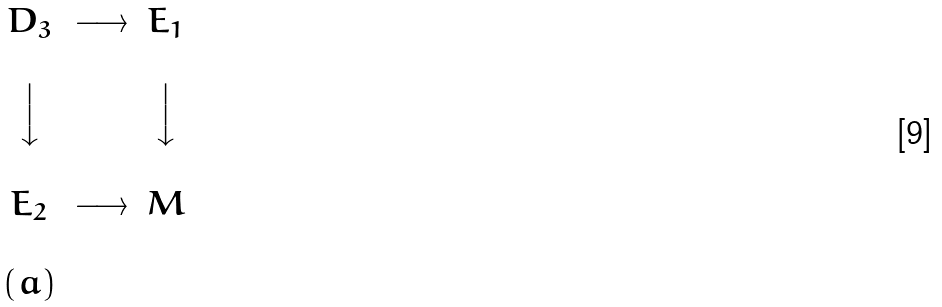Convert formula to latex. <formula><loc_0><loc_0><loc_500><loc_500>\begin{matrix} & & & \\ & D _ { 3 } & \longrightarrow & E _ { 1 } \\ & & & \\ & \Big \downarrow & & \Big \downarrow \\ & & & \\ & E _ { 2 } & \longrightarrow & M \\ & & & \\ & ( a ) & & \\ \end{matrix}</formula> 